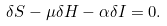Convert formula to latex. <formula><loc_0><loc_0><loc_500><loc_500>\delta S - \mu \delta H - \alpha \delta I = 0 .</formula> 